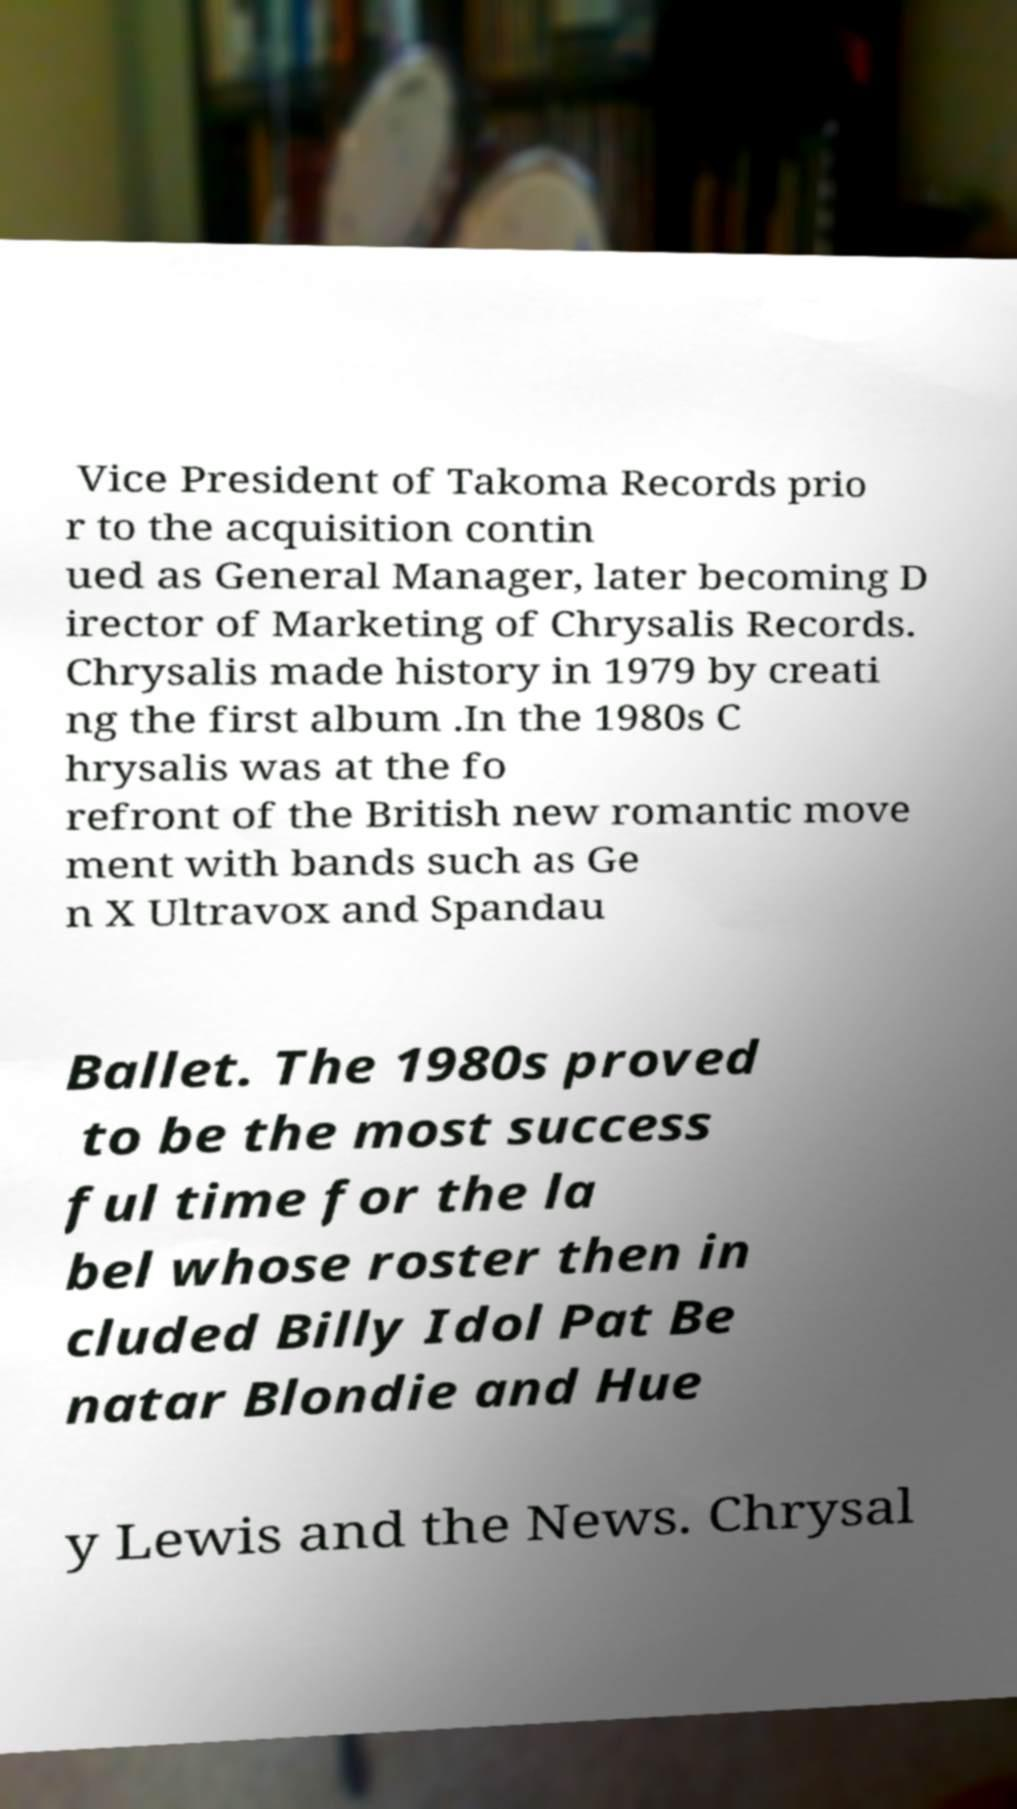Could you assist in decoding the text presented in this image and type it out clearly? Vice President of Takoma Records prio r to the acquisition contin ued as General Manager, later becoming D irector of Marketing of Chrysalis Records. Chrysalis made history in 1979 by creati ng the first album .In the 1980s C hrysalis was at the fo refront of the British new romantic move ment with bands such as Ge n X Ultravox and Spandau Ballet. The 1980s proved to be the most success ful time for the la bel whose roster then in cluded Billy Idol Pat Be natar Blondie and Hue y Lewis and the News. Chrysal 